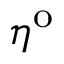<formula> <loc_0><loc_0><loc_500><loc_500>\eta ^ { o }</formula> 